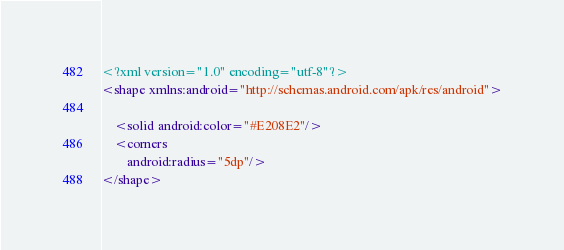<code> <loc_0><loc_0><loc_500><loc_500><_XML_><?xml version="1.0" encoding="utf-8"?>
<shape xmlns:android="http://schemas.android.com/apk/res/android">

    <solid android:color="#E208E2"/>
    <corners
        android:radius="5dp"/>
</shape></code> 